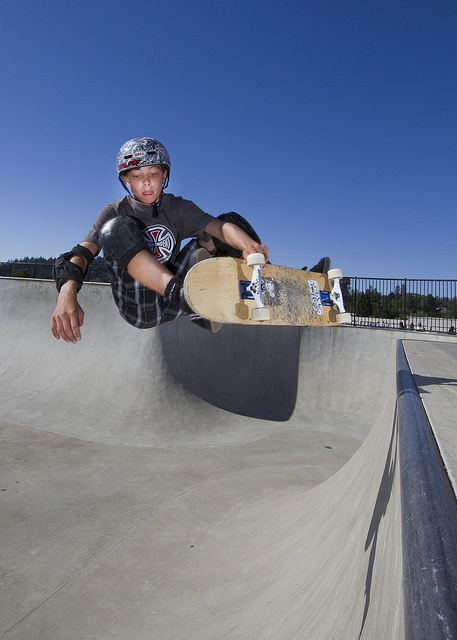Describe the objects in this image and their specific colors. I can see people in blue, black, gray, and darkgray tones, skateboard in blue, tan, darkgray, and gray tones, people in blue, darkgray, gray, black, and lightgray tones, people in blue, black, gray, darkgray, and navy tones, and people in blue, black, gray, and purple tones in this image. 